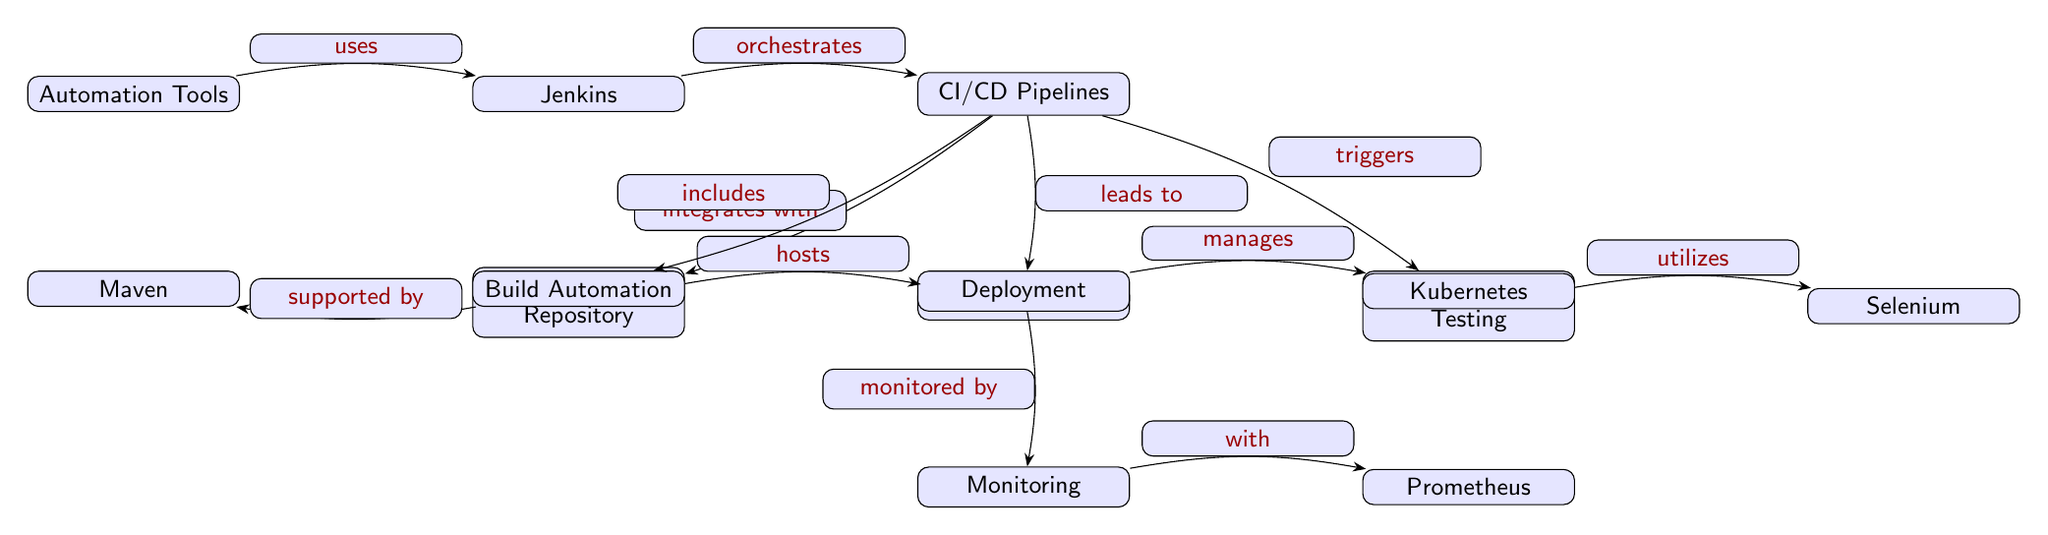What is the first node in the diagram? The first node in the diagram is labeled "Automation Tools," which is positioned at the top left.
Answer: Automation Tools How many nodes are present in the diagram? By counting each distinct node in the diagram, we see there are a total of 13 nodes arranged in different sections.
Answer: 13 What connection exists between Jenkins and CI/CD Pipelines? The diagram indicates that Jenkins "orchestrates" CI/CD Pipelines, demonstrating a direct action or relationship between these two nodes.
Answer: orchestrates Which node is directly below the Source Code Repository? The node directly below the "Source Code Repository" is labeled "GitHub," indicating it is hosted on this platform.
Answer: GitHub What role does Kubernetes play in the workflow? According to the diagram, Kubernetes is involved in the "Deployment" phase, suggesting its role is to manage application deployments.
Answer: manages How does CI/CD Pipelines relate to Automated Testing? The diagram shows that CI/CD Pipelines "triggers" Automated Testing, indicating a cause-effect relationship where pipelines initiate testing procedures.
Answer: triggers What does "Build Automation" utilize according to the diagram? The diagram specifies that "Build Automation" is "supported by" Maven, highlighting the tool used for automation in building applications.
Answer: Maven What is the relationship between Deployment and Monitoring? The diagram states that Deployment is "monitored by" Monitoring, indicating that monitoring activities oversee the deployment operations.
Answer: monitored by Which tool is utilized for Automated Testing? The diagram specifies that Selenium is the tool used for Automated Testing, showing its specific function within the testing process.
Answer: Selenium 